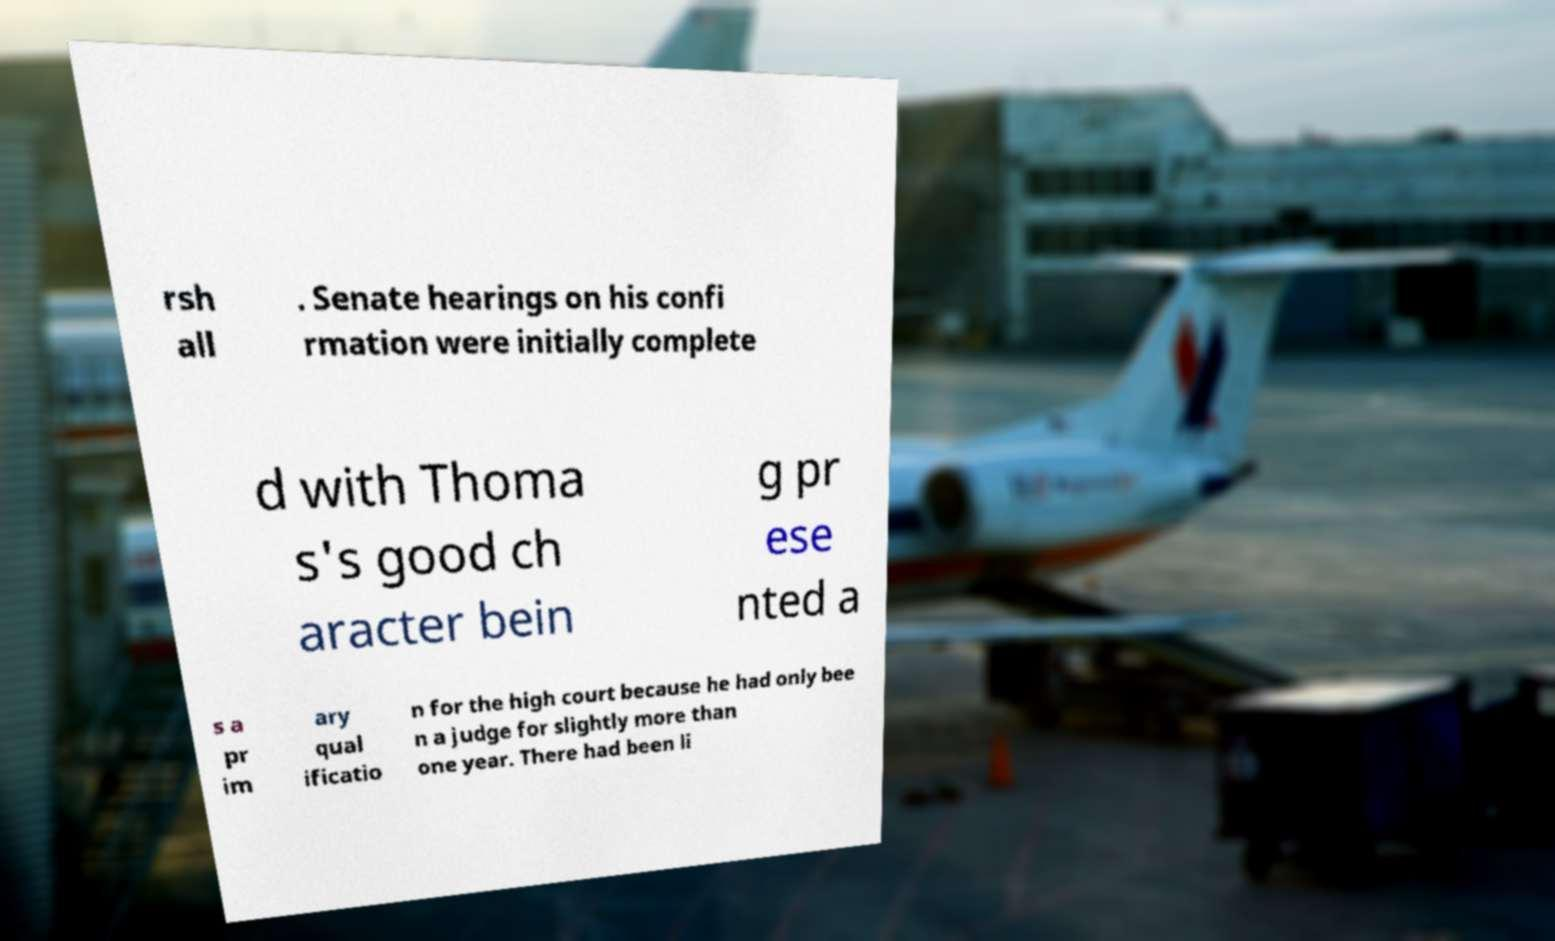Please read and relay the text visible in this image. What does it say? rsh all . Senate hearings on his confi rmation were initially complete d with Thoma s's good ch aracter bein g pr ese nted a s a pr im ary qual ificatio n for the high court because he had only bee n a judge for slightly more than one year. There had been li 